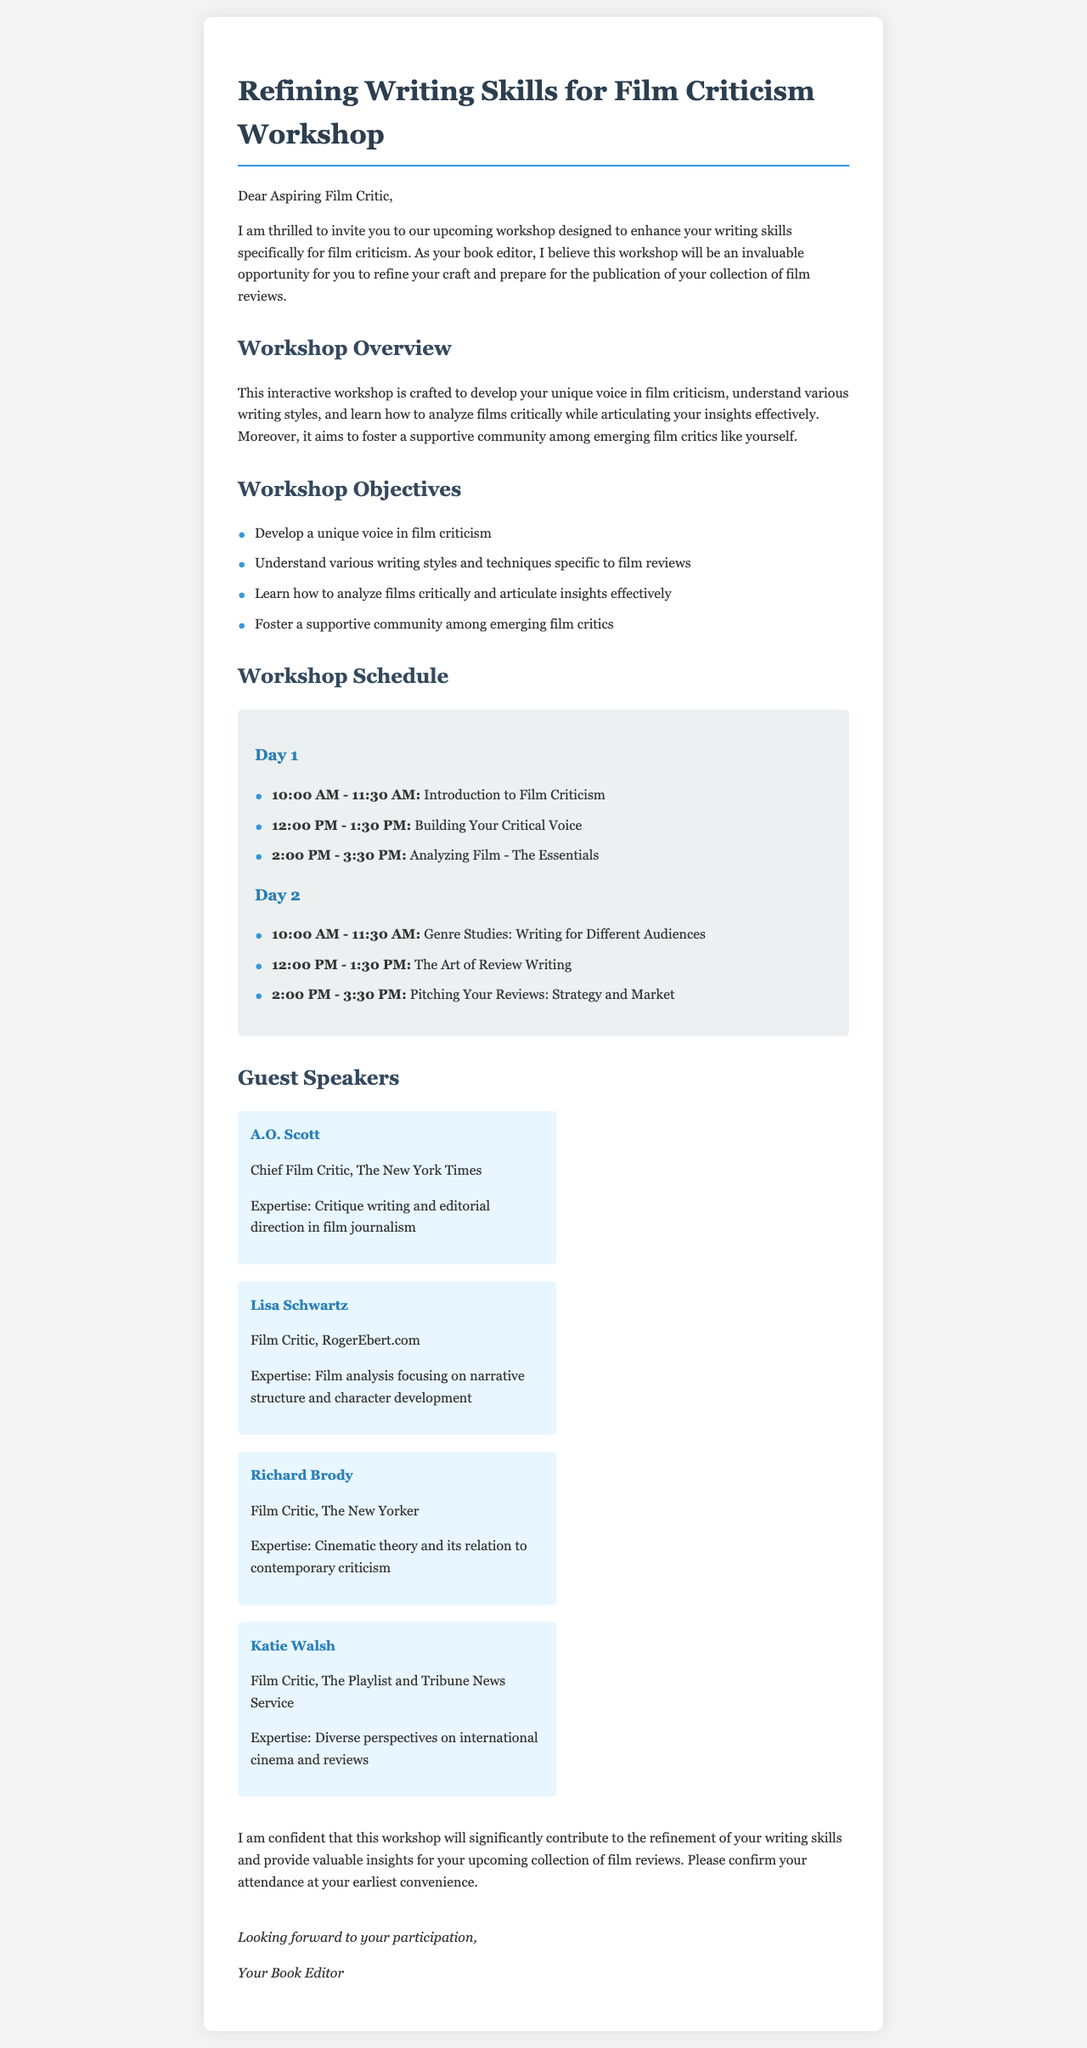what is the title of the workshop? The title of the workshop is stated at the beginning of the document.
Answer: Refining Writing Skills for Film Criticism Workshop who is the book editor mentioned in the letter? The book editor refers to the author of the letter who is encouraging the recipient.
Answer: Your Book Editor what is the date and time for the "Introduction to Film Criticism" session? The time for this session is specified in the workshop schedule.
Answer: 10:00 AM - 11:30 AM how many guest speakers are listed in the document? The document lists a total of four guest speakers mentioned.
Answer: 4 what is one objective of the workshop? The objectives are outlined in a list format within the document.
Answer: Develop a unique voice in film criticism what is the length of the workshop? The workshop lasts for two days, with a schedule detailing activities for each day.
Answer: 2 days who is a guest speaker from The New Yorker? The letter specifies the contributions of guest speakers, naming them specifically.
Answer: Richard Brody what time is the "Pitching Your Reviews: Strategy and Market" session? The time for this session can be found in the online schedule.
Answer: 2:00 PM - 3:30 PM 